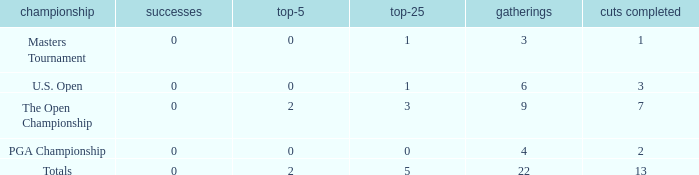What is the average number of cuts made for events with under 4 entries and more than 0 wins? None. 